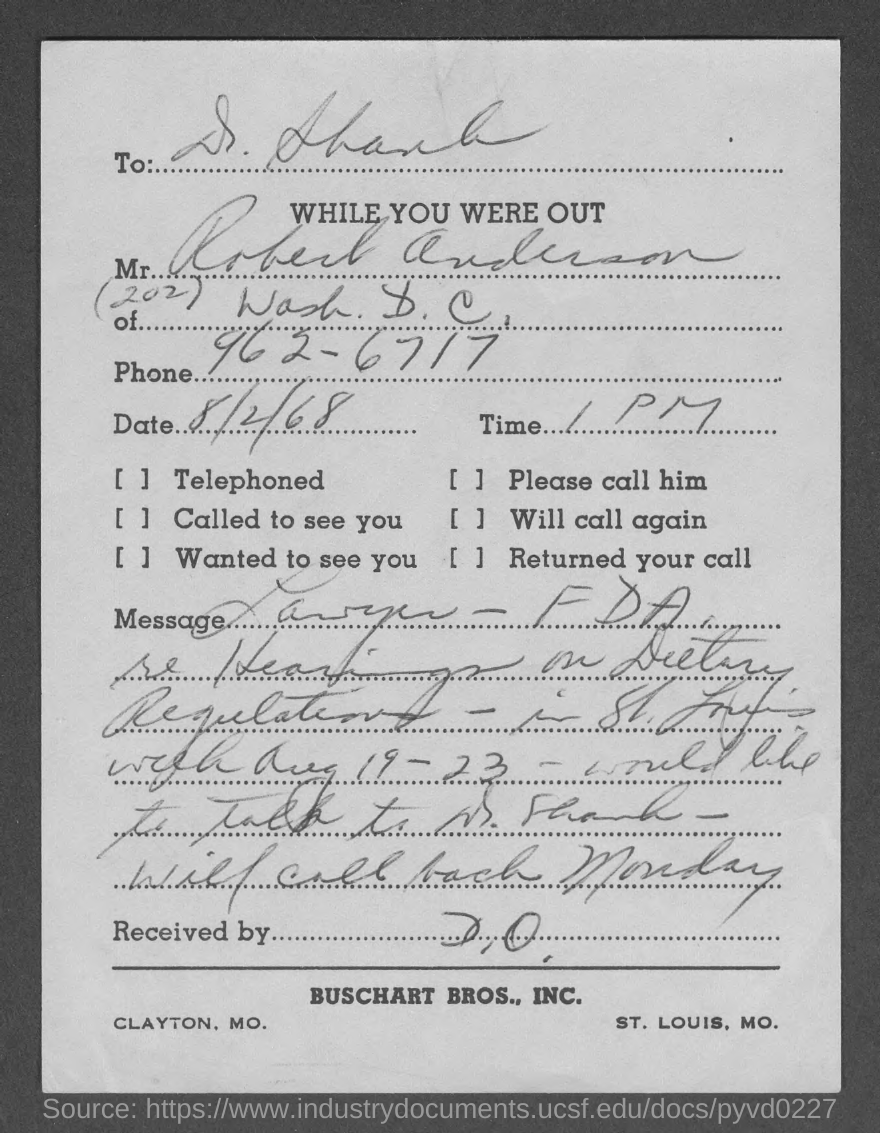Who is this letter from?
Ensure brevity in your answer.  Robert Anderson. What is the Phone?
Your response must be concise. 962-6717. What is the Date?
Provide a short and direct response. 8/2/68. What is the time?
Offer a very short reply. 1 pm. 